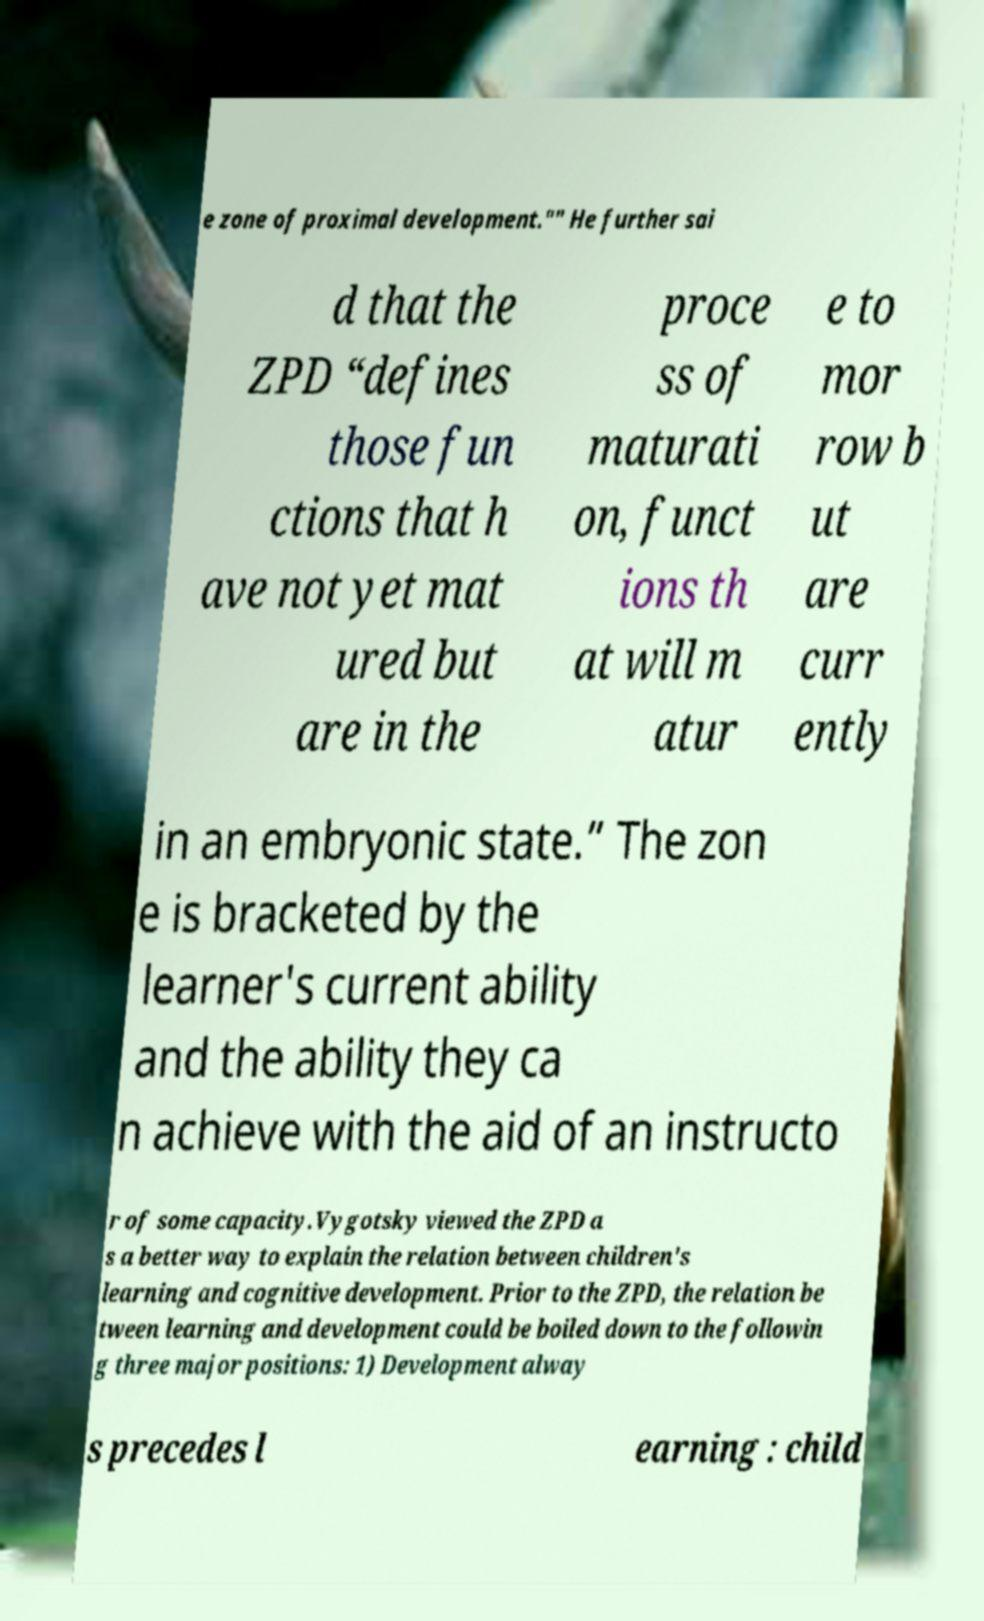What messages or text are displayed in this image? I need them in a readable, typed format. e zone of proximal development."" He further sai d that the ZPD “defines those fun ctions that h ave not yet mat ured but are in the proce ss of maturati on, funct ions th at will m atur e to mor row b ut are curr ently in an embryonic state.” The zon e is bracketed by the learner's current ability and the ability they ca n achieve with the aid of an instructo r of some capacity.Vygotsky viewed the ZPD a s a better way to explain the relation between children's learning and cognitive development. Prior to the ZPD, the relation be tween learning and development could be boiled down to the followin g three major positions: 1) Development alway s precedes l earning : child 